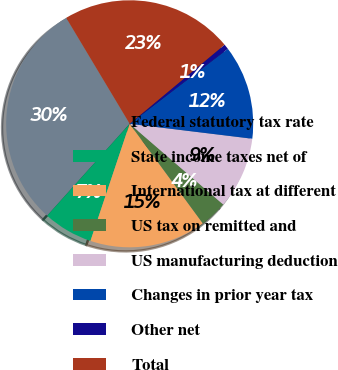<chart> <loc_0><loc_0><loc_500><loc_500><pie_chart><fcel>Federal statutory tax rate<fcel>State income taxes net of<fcel>International tax at different<fcel>US tax on remitted and<fcel>US manufacturing deduction<fcel>Changes in prior year tax<fcel>Other net<fcel>Total<nl><fcel>29.76%<fcel>6.5%<fcel>15.22%<fcel>3.59%<fcel>9.4%<fcel>12.31%<fcel>0.68%<fcel>22.53%<nl></chart> 